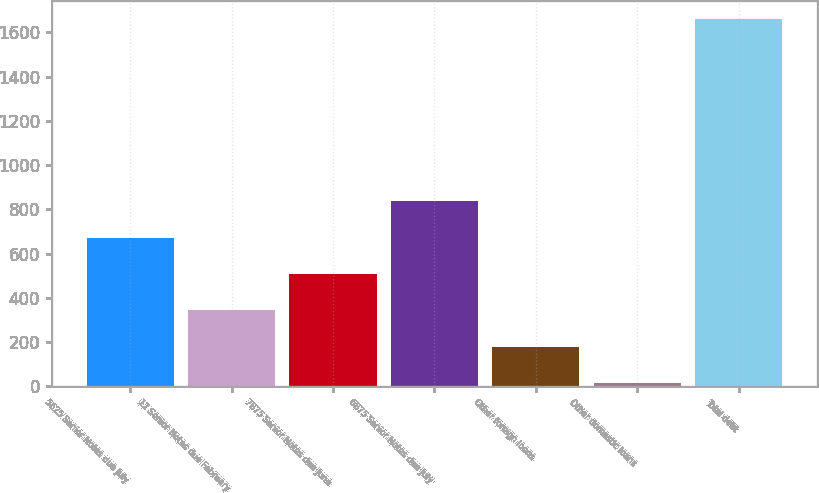<chart> <loc_0><loc_0><loc_500><loc_500><bar_chart><fcel>5625 Senior Notes due July<fcel>12 Senior Notes due February<fcel>7875 Senior Notes due June<fcel>6875 Senior Notes due July<fcel>Other foreign loans<fcel>Other domestic loans<fcel>Total debt<nl><fcel>672.08<fcel>342.44<fcel>507.26<fcel>836.9<fcel>177.62<fcel>12.8<fcel>1661<nl></chart> 